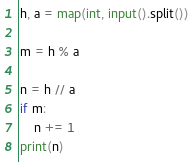Convert code to text. <code><loc_0><loc_0><loc_500><loc_500><_Python_>h, a = map(int, input().split())

m = h % a

n = h // a 
if m:
    n += 1
print(n)
</code> 